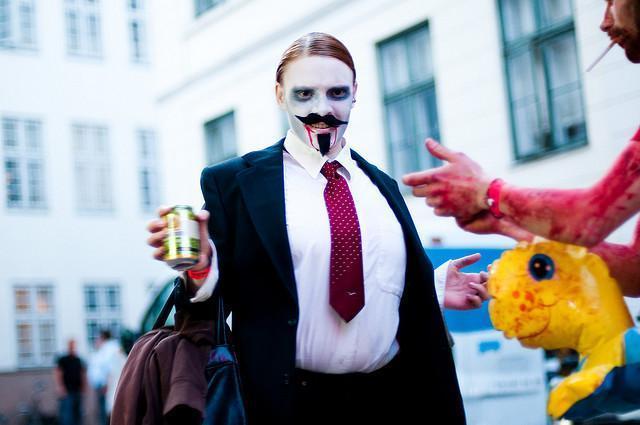How many handbags are there?
Give a very brief answer. 2. How many people are in the picture?
Give a very brief answer. 3. 